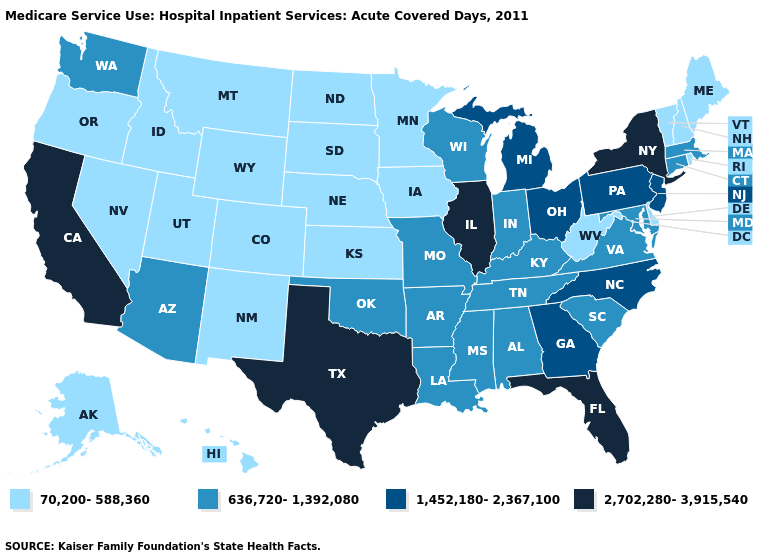What is the value of North Dakota?
Concise answer only. 70,200-588,360. Name the states that have a value in the range 2,702,280-3,915,540?
Concise answer only. California, Florida, Illinois, New York, Texas. Name the states that have a value in the range 636,720-1,392,080?
Be succinct. Alabama, Arizona, Arkansas, Connecticut, Indiana, Kentucky, Louisiana, Maryland, Massachusetts, Mississippi, Missouri, Oklahoma, South Carolina, Tennessee, Virginia, Washington, Wisconsin. What is the value of West Virginia?
Give a very brief answer. 70,200-588,360. Does Idaho have the lowest value in the West?
Answer briefly. Yes. Which states have the lowest value in the USA?
Write a very short answer. Alaska, Colorado, Delaware, Hawaii, Idaho, Iowa, Kansas, Maine, Minnesota, Montana, Nebraska, Nevada, New Hampshire, New Mexico, North Dakota, Oregon, Rhode Island, South Dakota, Utah, Vermont, West Virginia, Wyoming. What is the value of West Virginia?
Keep it brief. 70,200-588,360. Name the states that have a value in the range 70,200-588,360?
Keep it brief. Alaska, Colorado, Delaware, Hawaii, Idaho, Iowa, Kansas, Maine, Minnesota, Montana, Nebraska, Nevada, New Hampshire, New Mexico, North Dakota, Oregon, Rhode Island, South Dakota, Utah, Vermont, West Virginia, Wyoming. What is the value of Connecticut?
Concise answer only. 636,720-1,392,080. What is the value of Hawaii?
Short answer required. 70,200-588,360. Does Rhode Island have a lower value than Florida?
Short answer required. Yes. Does New Jersey have the lowest value in the Northeast?
Be succinct. No. What is the value of Georgia?
Answer briefly. 1,452,180-2,367,100. Name the states that have a value in the range 636,720-1,392,080?
Be succinct. Alabama, Arizona, Arkansas, Connecticut, Indiana, Kentucky, Louisiana, Maryland, Massachusetts, Mississippi, Missouri, Oklahoma, South Carolina, Tennessee, Virginia, Washington, Wisconsin. Does Illinois have the highest value in the MidWest?
Be succinct. Yes. 